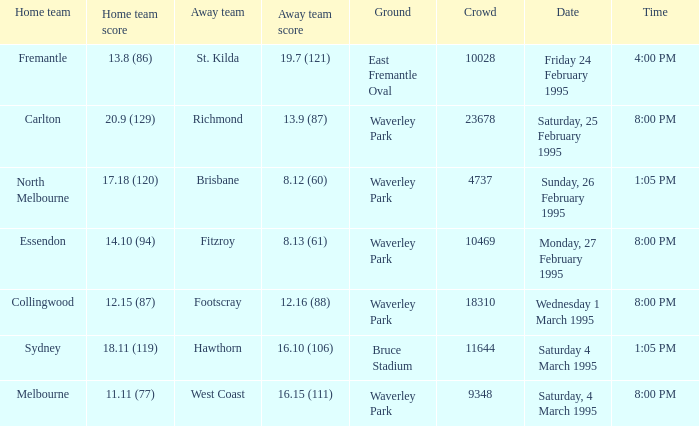Name the ground for essendon Waverley Park. 